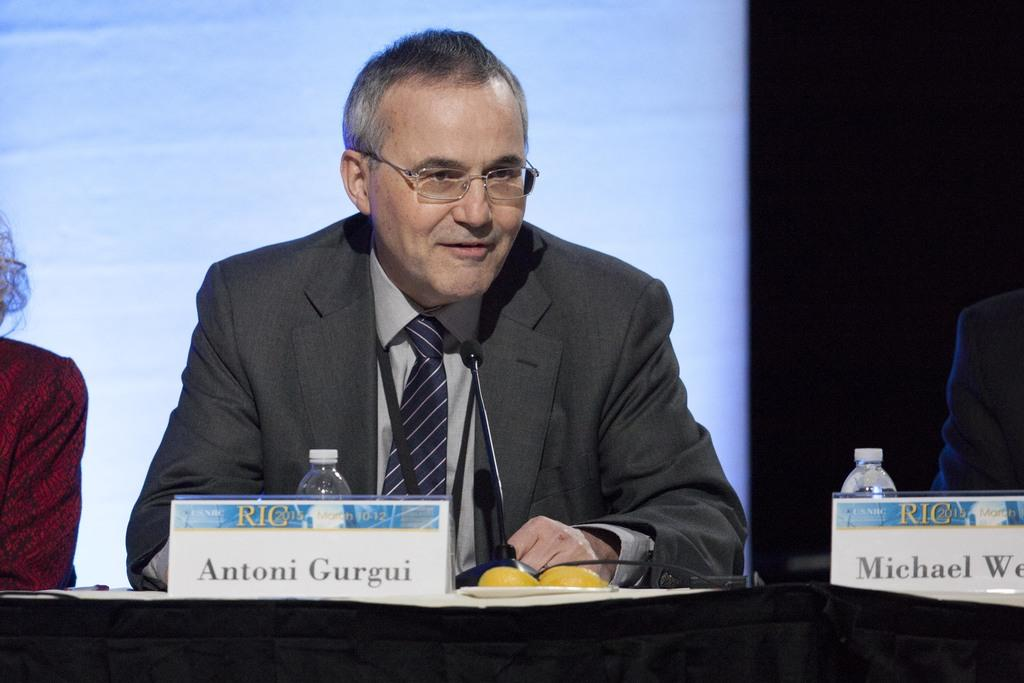What is the person in the image wearing? The person in the image is wearing specs. What is in front of the person? There is a table in front of the person. What can be seen on the table? There are bottles, name boards, a mic, and other items on the table. What type of canvas is visible in the image? There is no canvas present in the image. Can you describe the bath that is visible in the image? There is no bath present in the image. 